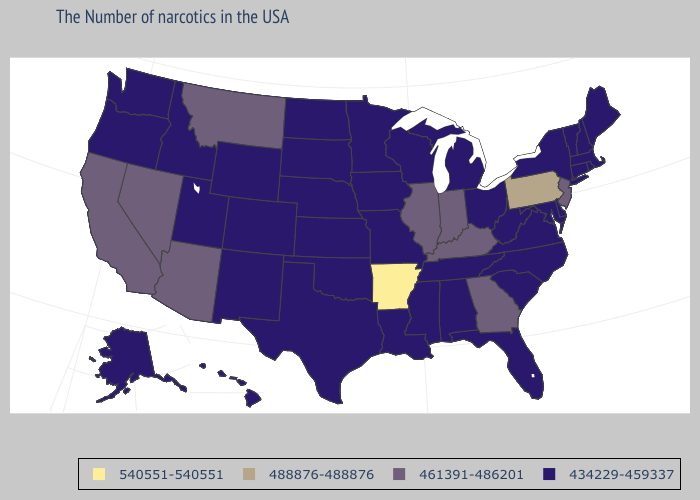What is the highest value in the MidWest ?
Concise answer only. 461391-486201. Name the states that have a value in the range 488876-488876?
Be succinct. Pennsylvania. Which states hav the highest value in the MidWest?
Be succinct. Indiana, Illinois. Does Mississippi have the lowest value in the South?
Short answer required. Yes. Name the states that have a value in the range 434229-459337?
Keep it brief. Maine, Massachusetts, Rhode Island, New Hampshire, Vermont, Connecticut, New York, Delaware, Maryland, Virginia, North Carolina, South Carolina, West Virginia, Ohio, Florida, Michigan, Alabama, Tennessee, Wisconsin, Mississippi, Louisiana, Missouri, Minnesota, Iowa, Kansas, Nebraska, Oklahoma, Texas, South Dakota, North Dakota, Wyoming, Colorado, New Mexico, Utah, Idaho, Washington, Oregon, Alaska, Hawaii. Is the legend a continuous bar?
Concise answer only. No. What is the value of Maine?
Give a very brief answer. 434229-459337. Does the first symbol in the legend represent the smallest category?
Concise answer only. No. Does the map have missing data?
Concise answer only. No. What is the value of New York?
Answer briefly. 434229-459337. Which states hav the highest value in the Northeast?
Quick response, please. Pennsylvania. What is the value of New Mexico?
Short answer required. 434229-459337. Name the states that have a value in the range 461391-486201?
Keep it brief. New Jersey, Georgia, Kentucky, Indiana, Illinois, Montana, Arizona, Nevada, California. What is the value of Colorado?
Quick response, please. 434229-459337. Does Georgia have the lowest value in the USA?
Write a very short answer. No. 